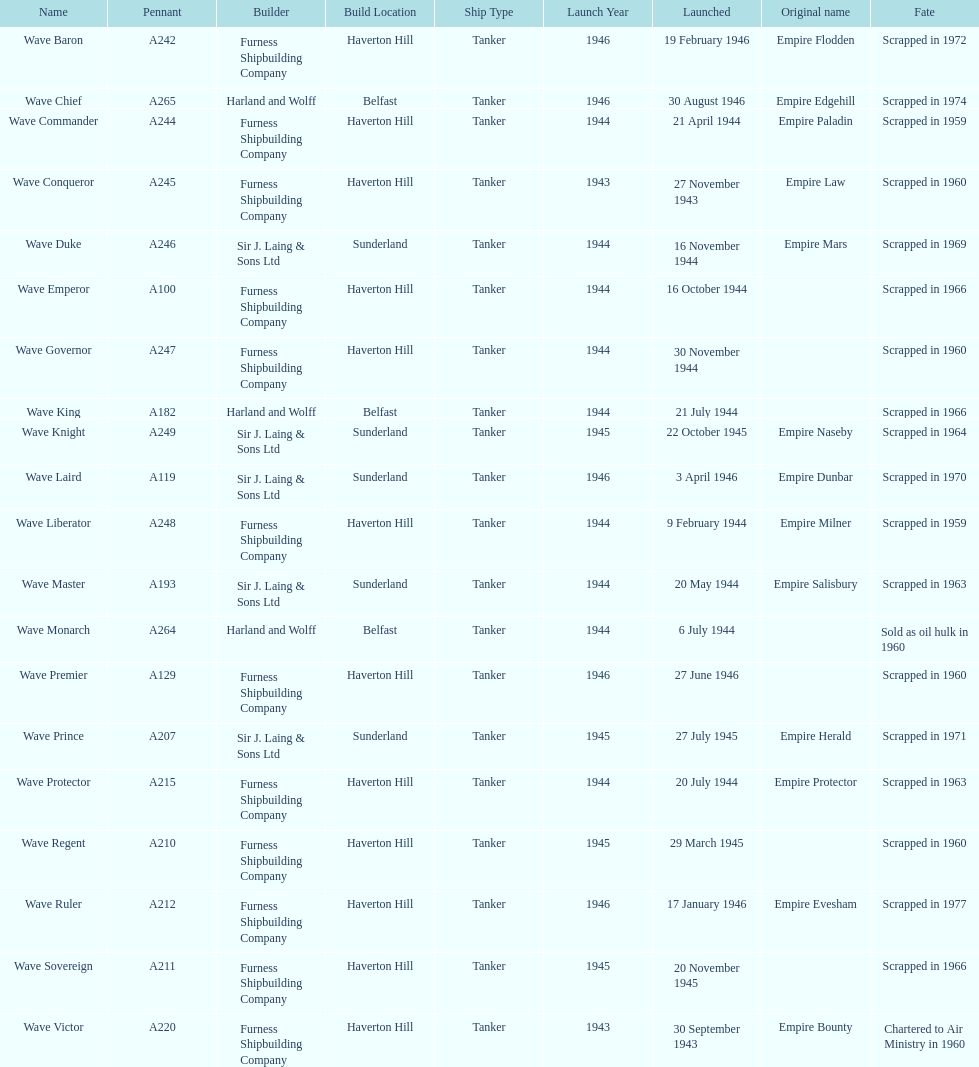When was the first vessel launched? 30 September 1943. 